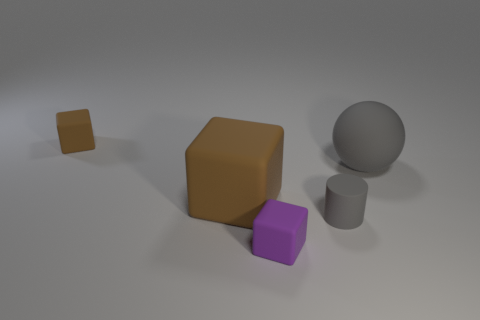Are there any tiny gray things made of the same material as the gray sphere?
Offer a very short reply. Yes. The other brown rubber object that is the same shape as the small brown rubber thing is what size?
Your answer should be compact. Large. Are there an equal number of big blocks to the left of the tiny brown cube and small purple things?
Make the answer very short. No. There is a matte object that is to the left of the large brown matte thing; is it the same shape as the large brown matte thing?
Provide a succinct answer. Yes. There is a big gray matte thing; what shape is it?
Ensure brevity in your answer.  Sphere. What is the material of the tiny cube that is on the right side of the brown cube that is to the right of the tiny rubber object to the left of the tiny purple block?
Your answer should be compact. Rubber. There is a thing that is the same color as the cylinder; what material is it?
Your answer should be compact. Rubber. What number of things are either small red shiny cylinders or big matte objects?
Your response must be concise. 2. Is the material of the big object to the right of the tiny purple matte cube the same as the big cube?
Offer a terse response. Yes. How many objects are gray things on the right side of the tiny cylinder or matte blocks?
Provide a short and direct response. 4. 